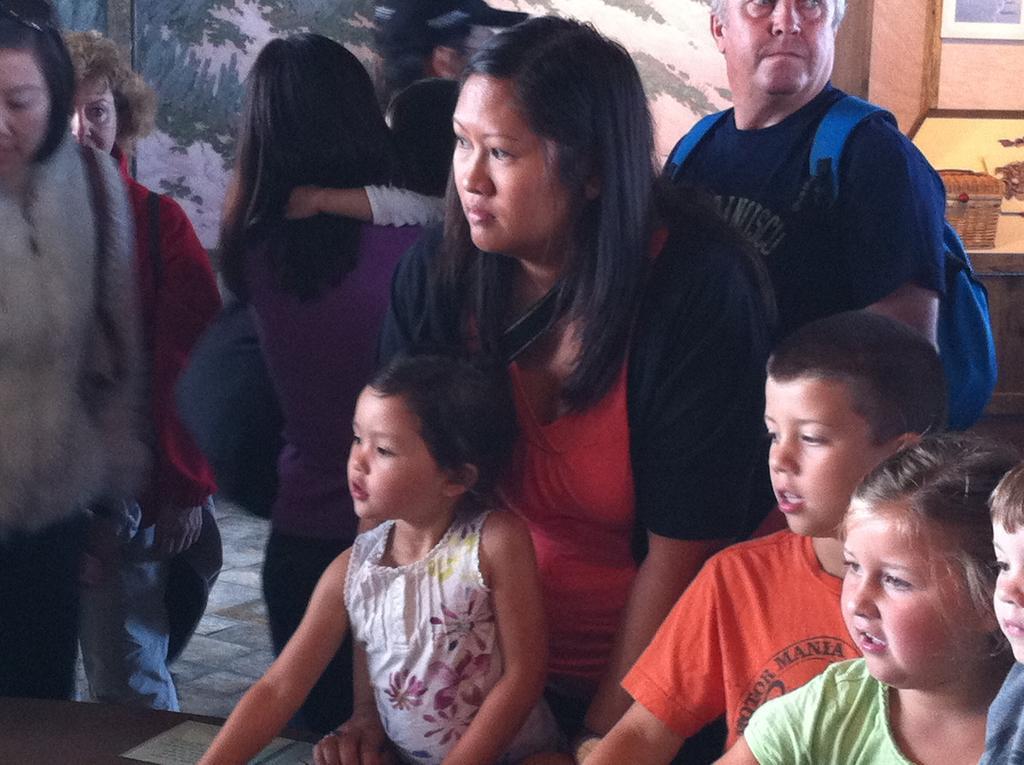In one or two sentences, can you explain what this image depicts? In this picture we can see few persons. Here we can see girls and boys. Behind them we can see one women standing and on the right side of the picture we can see a man wearing blue backpack. On left side of the picture we can see two women standing. 